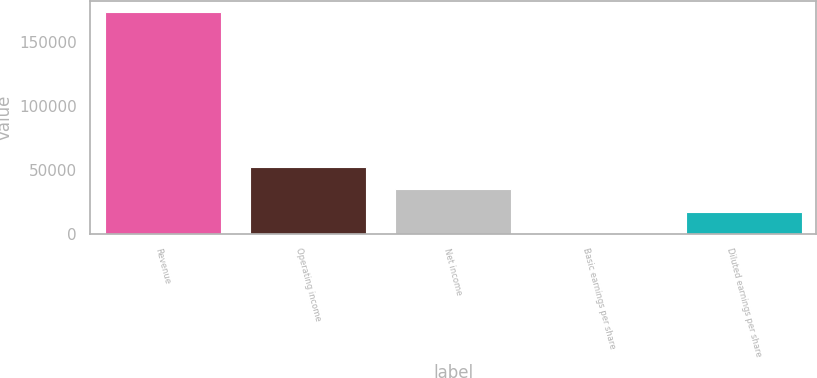<chart> <loc_0><loc_0><loc_500><loc_500><bar_chart><fcel>Revenue<fcel>Operating income<fcel>Net income<fcel>Basic earnings per share<fcel>Diluted earnings per share<nl><fcel>173313<fcel>51994<fcel>34662.7<fcel>0.16<fcel>17331.4<nl></chart> 